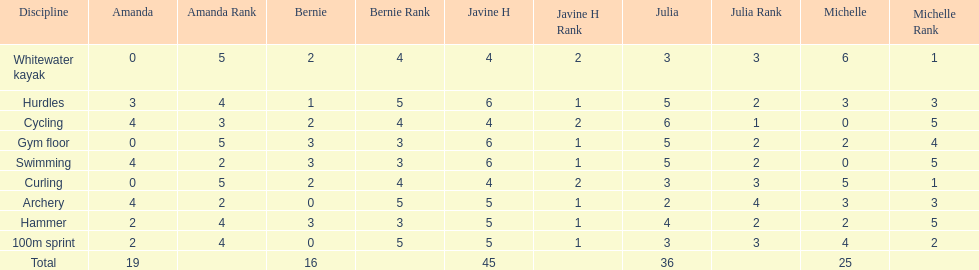Could you parse the entire table as a dict? {'header': ['Discipline', 'Amanda', 'Amanda Rank', 'Bernie', 'Bernie Rank', 'Javine H', 'Javine H Rank', 'Julia', 'Julia Rank', 'Michelle', 'Michelle Rank'], 'rows': [['Whitewater kayak', '0', '5', '2', '4', '4', '2', '3', '3', '6', '1'], ['Hurdles', '3', '4', '1', '5', '6', '1', '5', '2', '3', '3'], ['Cycling', '4', '3', '2', '4', '4', '2', '6', '1', '0', '5'], ['Gym floor', '0', '5', '3', '3', '6', '1', '5', '2', '2', '4'], ['Swimming', '4', '2', '3', '3', '6', '1', '5', '2', '0', '5'], ['Curling', '0', '5', '2', '4', '4', '2', '3', '3', '5', '1'], ['Archery', '4', '2', '0', '5', '5', '1', '2', '4', '3', '3'], ['Hammer', '2', '4', '3', '3', '5', '1', '4', '2', '2', '5'], ['100m sprint', '2', '4', '0', '5', '5', '1', '3', '3', '4', '2'], ['Total', '19', '', '16', '', '45', '', '36', '', '25', '']]} What is the average score on 100m sprint? 2.8. 